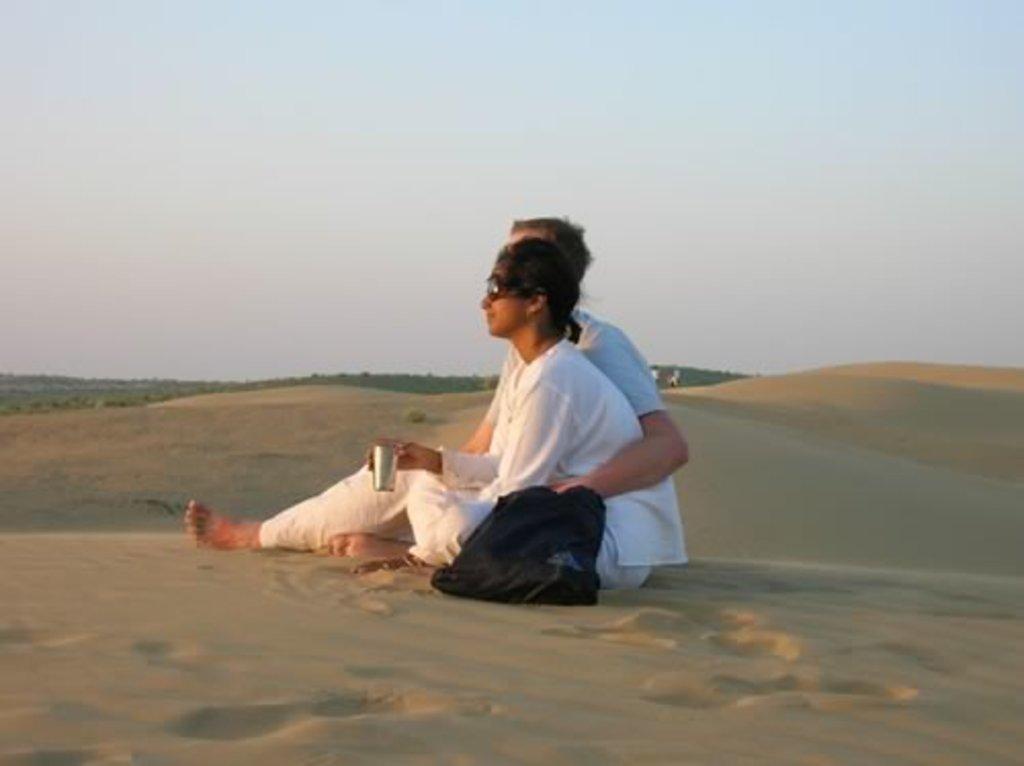In one or two sentences, can you explain what this image depicts? In front of the image there are two people sitting on the sand where one person is holding the glass. Beside them there is a bag. Behind them there are a few other people standing. In the background of the image there are trees. At the top of the image there is sky. 